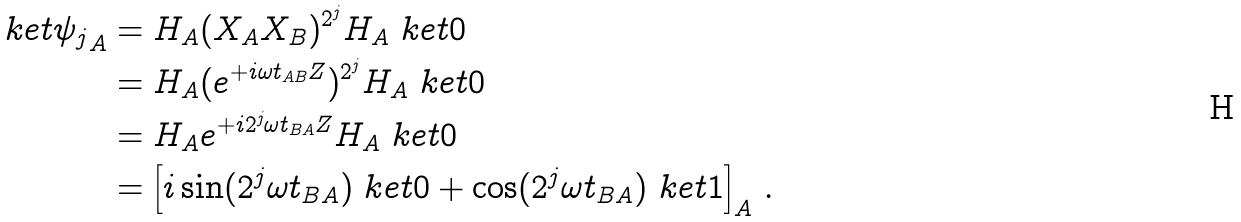<formula> <loc_0><loc_0><loc_500><loc_500>\ k e t { \psi _ { j } } _ { A } & = H _ { A } ( X _ { A } X _ { B } ) ^ { 2 ^ { j } } H _ { A } \ k e t { 0 } \\ & = H _ { A } ( e ^ { + i \omega t _ { A B } Z } ) ^ { 2 ^ { j } } H _ { A } \ k e t { 0 } \\ & = H _ { A } e ^ { + i 2 ^ { j } \omega t _ { B A } Z } H _ { A } \ k e t { 0 } \\ & = \left [ i \sin ( 2 ^ { j } \omega t _ { B A } ) \ k e t { 0 } + \cos ( 2 ^ { j } \omega t _ { B A } ) \ k e t { 1 } \right ] _ { A } \, .</formula> 